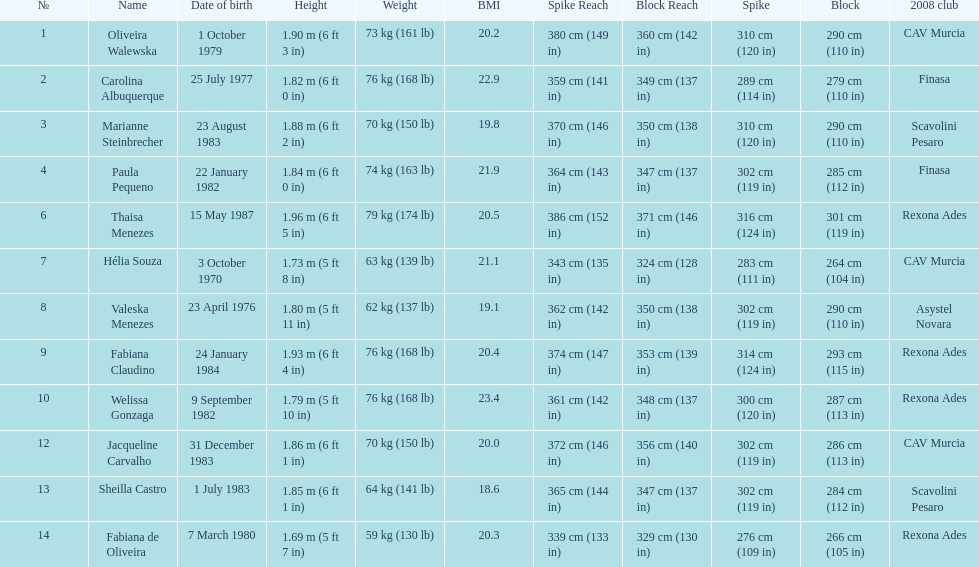Who is the next tallest player after thaisa menezes? Fabiana Claudino. 